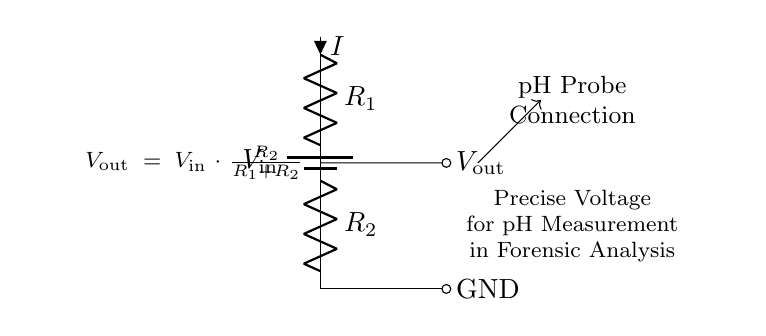What are the components in this circuit? The circuit consists of a battery, two resistors labeled as R1 and R2, and connections for output and ground.
Answer: battery, R1, R2 What is the output voltage formula? The output voltage is calculated using the formula Vout = Vin * (R2 / (R1 + R2)), which defines how the input voltage is divided between the two resistors.
Answer: Vout = Vin * (R2 / (R1 + R2)) How can we interpret the relationship between R1 and R2? The output voltage is dependent on the ratio of R2 to the total resistance (R1 + R2). A larger R2 will increase Vout, while a larger R1 will decrease it.
Answer: Vout is affected by the ratio of R2 to R1+R2 What is the purpose of this voltage divider in the circuit? The voltage divider is used to obtain a precise output voltage suitable for connecting to a pH probe for accurate pH measurement in forensic analysis.
Answer: precise voltage for pH measurement If R1 is 10 kOhm and R2 is 5 kOhm, what would be the output voltage if Vin is 15V? Using the formula Vout = 15V * (5 kOhm / (10 kOhm + 5 kOhm)) = 15V * (5/15) = 5V.
Answer: 5V What does the arrow labeled 'I' signify in the diagram? The arrow labeled 'I' indicates the direction of current flowing through resistor R1, which helps understand how current travels in the circuit.
Answer: current direction Why is grounding important in this circuit? Grounding provides a common reference point for the voltage measurements, ensuring that the output voltage (Vout) is accurate relative to the earth's potential, which is crucial for reliable pH measurements.
Answer: ensures accurate voltage reference 